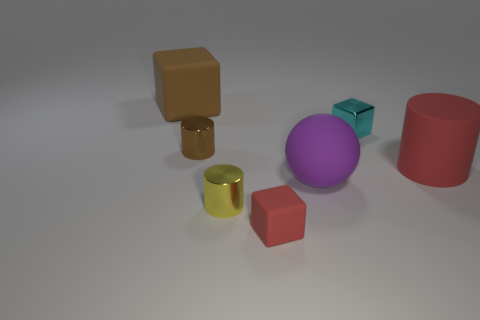Subtract 1 cylinders. How many cylinders are left? 2 Add 1 tiny red matte objects. How many objects exist? 8 Subtract all cylinders. How many objects are left? 4 Subtract all blue metal objects. Subtract all large rubber cylinders. How many objects are left? 6 Add 4 brown matte objects. How many brown matte objects are left? 5 Add 6 tiny blue balls. How many tiny blue balls exist? 6 Subtract 1 cyan blocks. How many objects are left? 6 